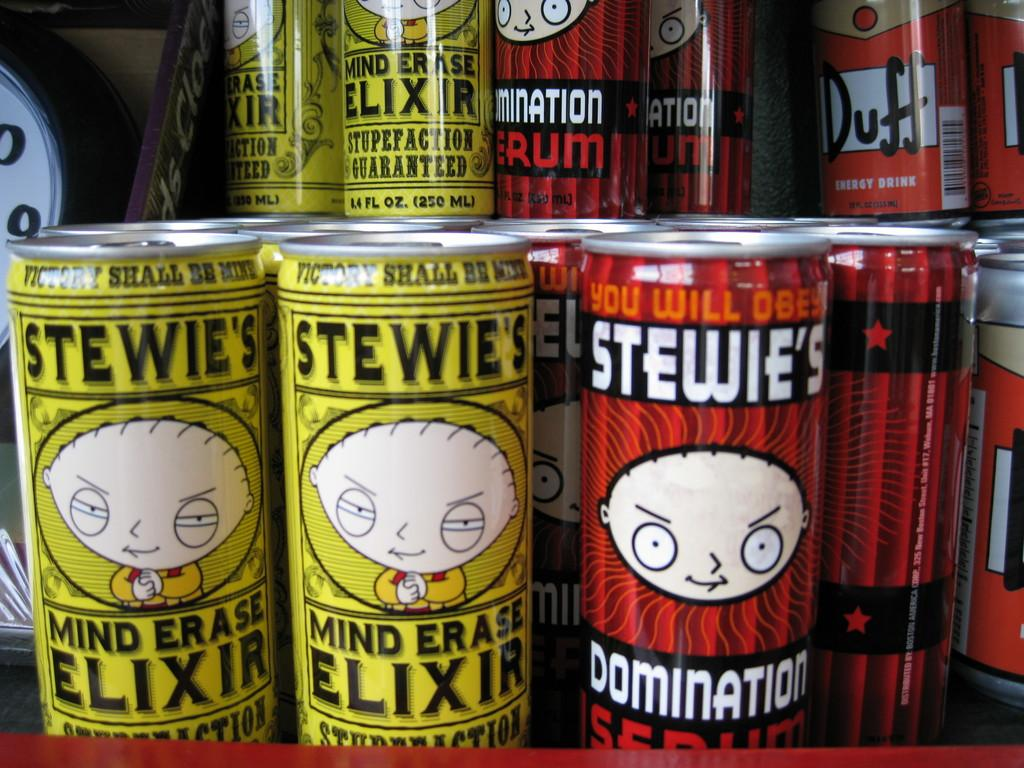<image>
Share a concise interpretation of the image provided. A yellow can says Stewie's mind altering elixer 